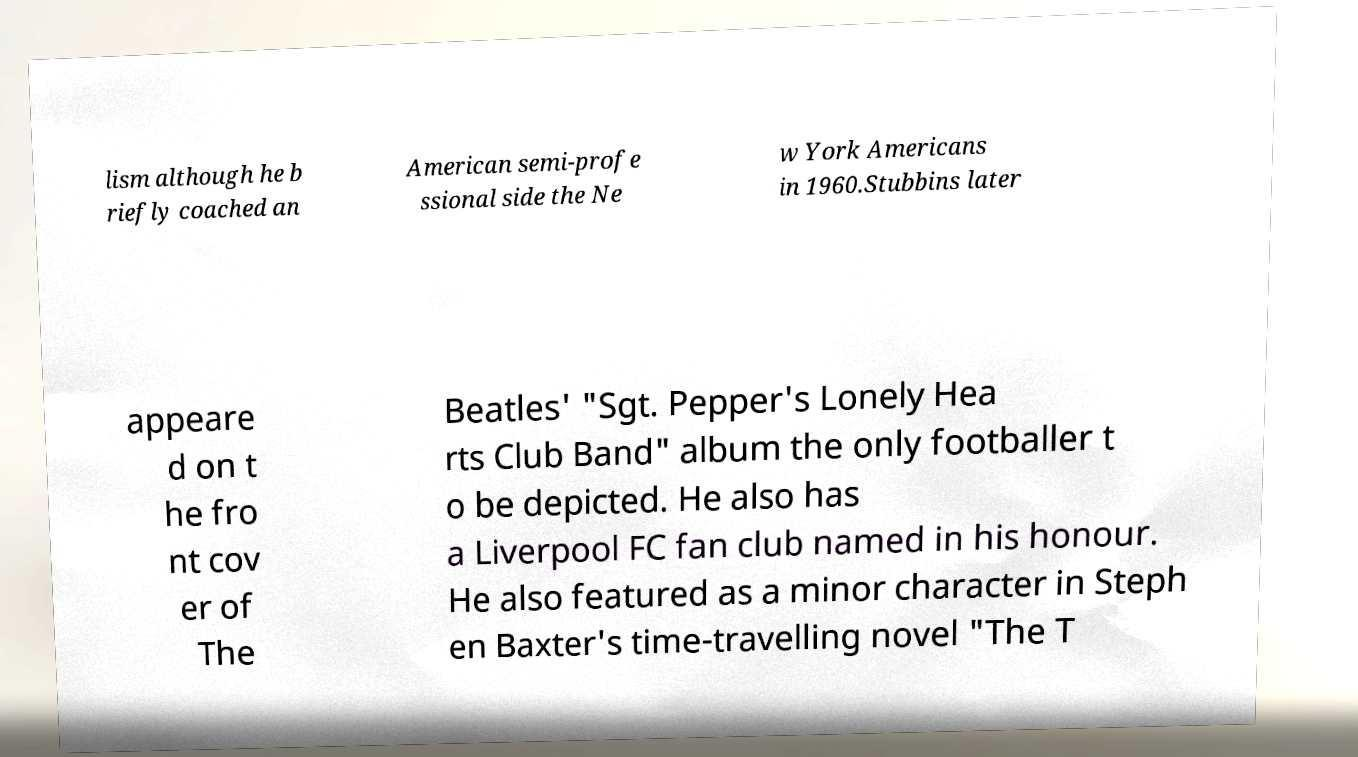There's text embedded in this image that I need extracted. Can you transcribe it verbatim? lism although he b riefly coached an American semi-profe ssional side the Ne w York Americans in 1960.Stubbins later appeare d on t he fro nt cov er of The Beatles' "Sgt. Pepper's Lonely Hea rts Club Band" album the only footballer t o be depicted. He also has a Liverpool FC fan club named in his honour. He also featured as a minor character in Steph en Baxter's time-travelling novel "The T 